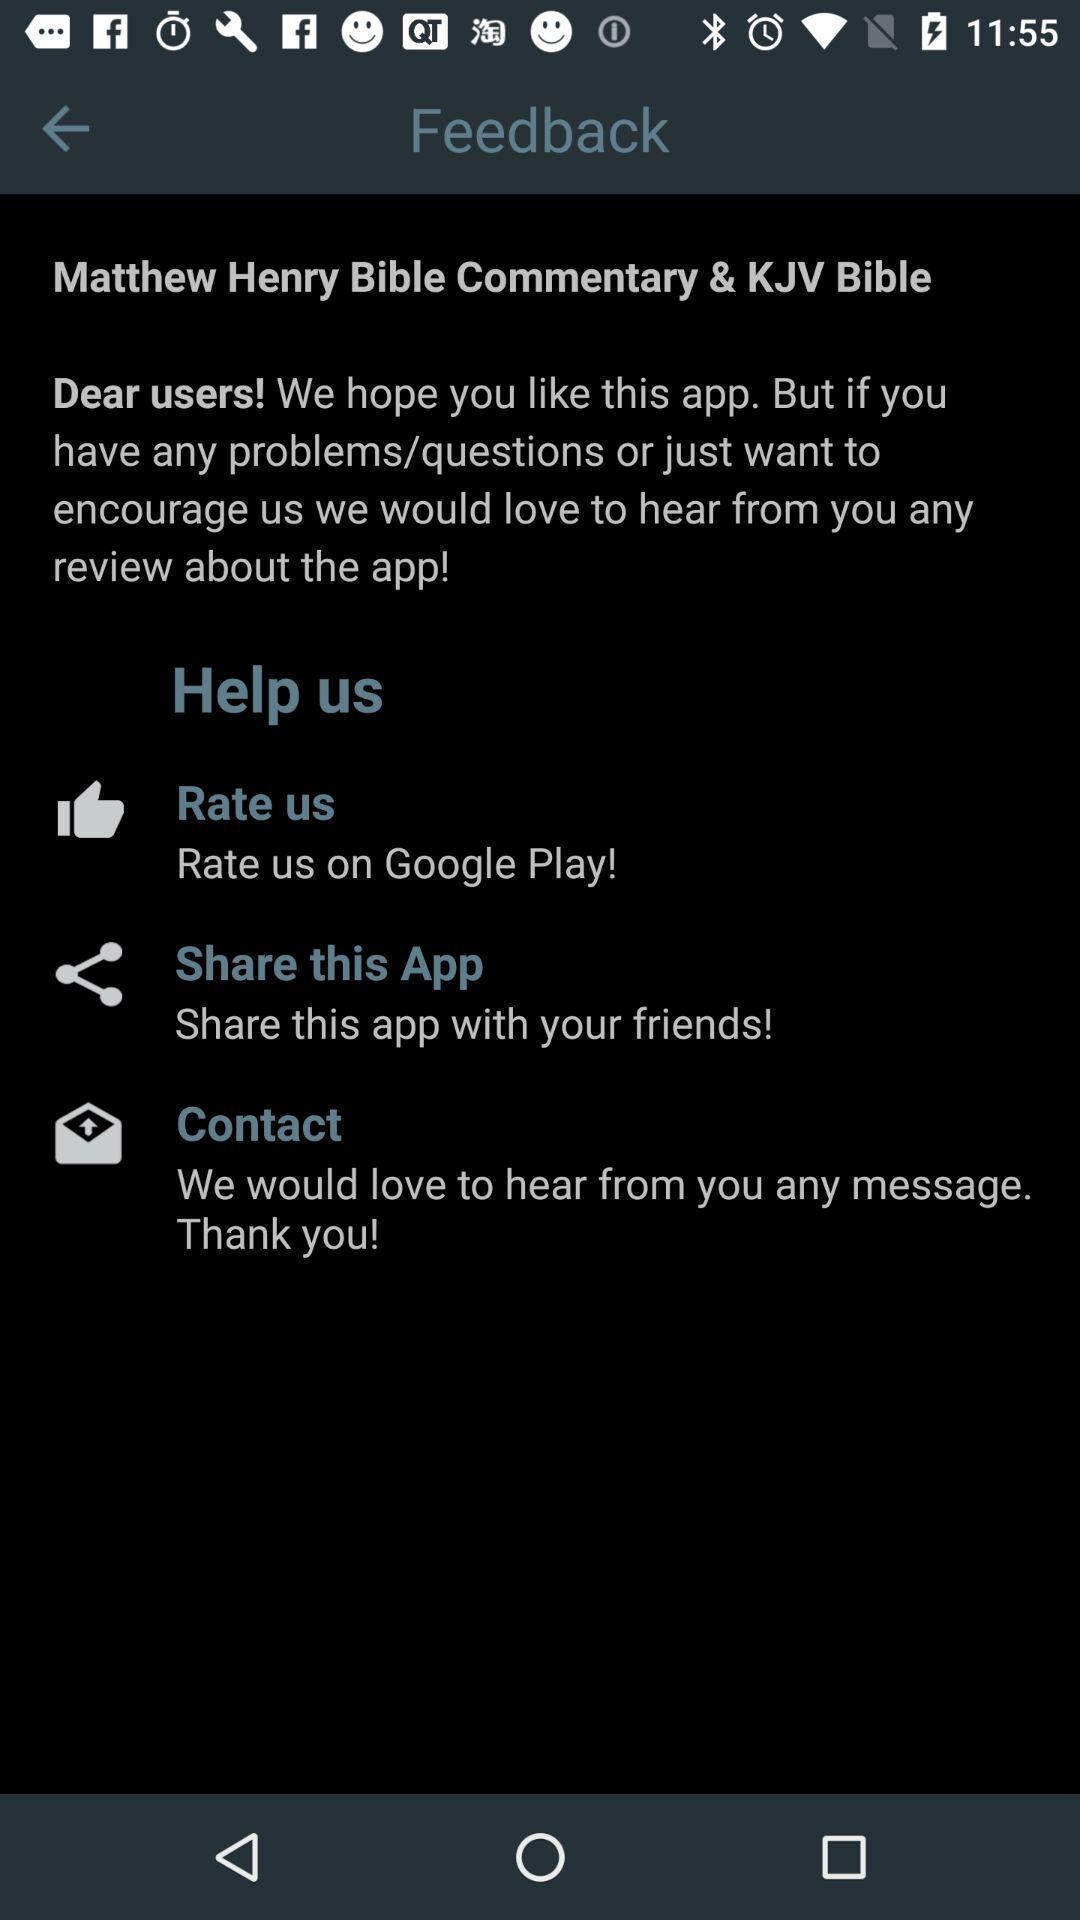Give me a narrative description of this picture. Page displaying information. 